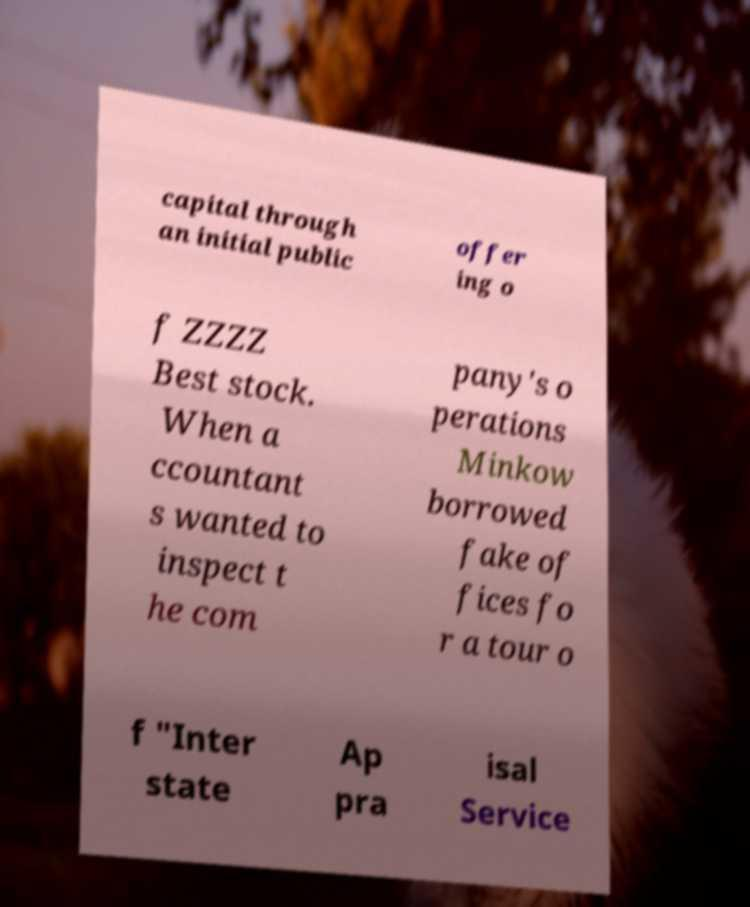Can you read and provide the text displayed in the image?This photo seems to have some interesting text. Can you extract and type it out for me? capital through an initial public offer ing o f ZZZZ Best stock. When a ccountant s wanted to inspect t he com pany's o perations Minkow borrowed fake of fices fo r a tour o f "Inter state Ap pra isal Service 